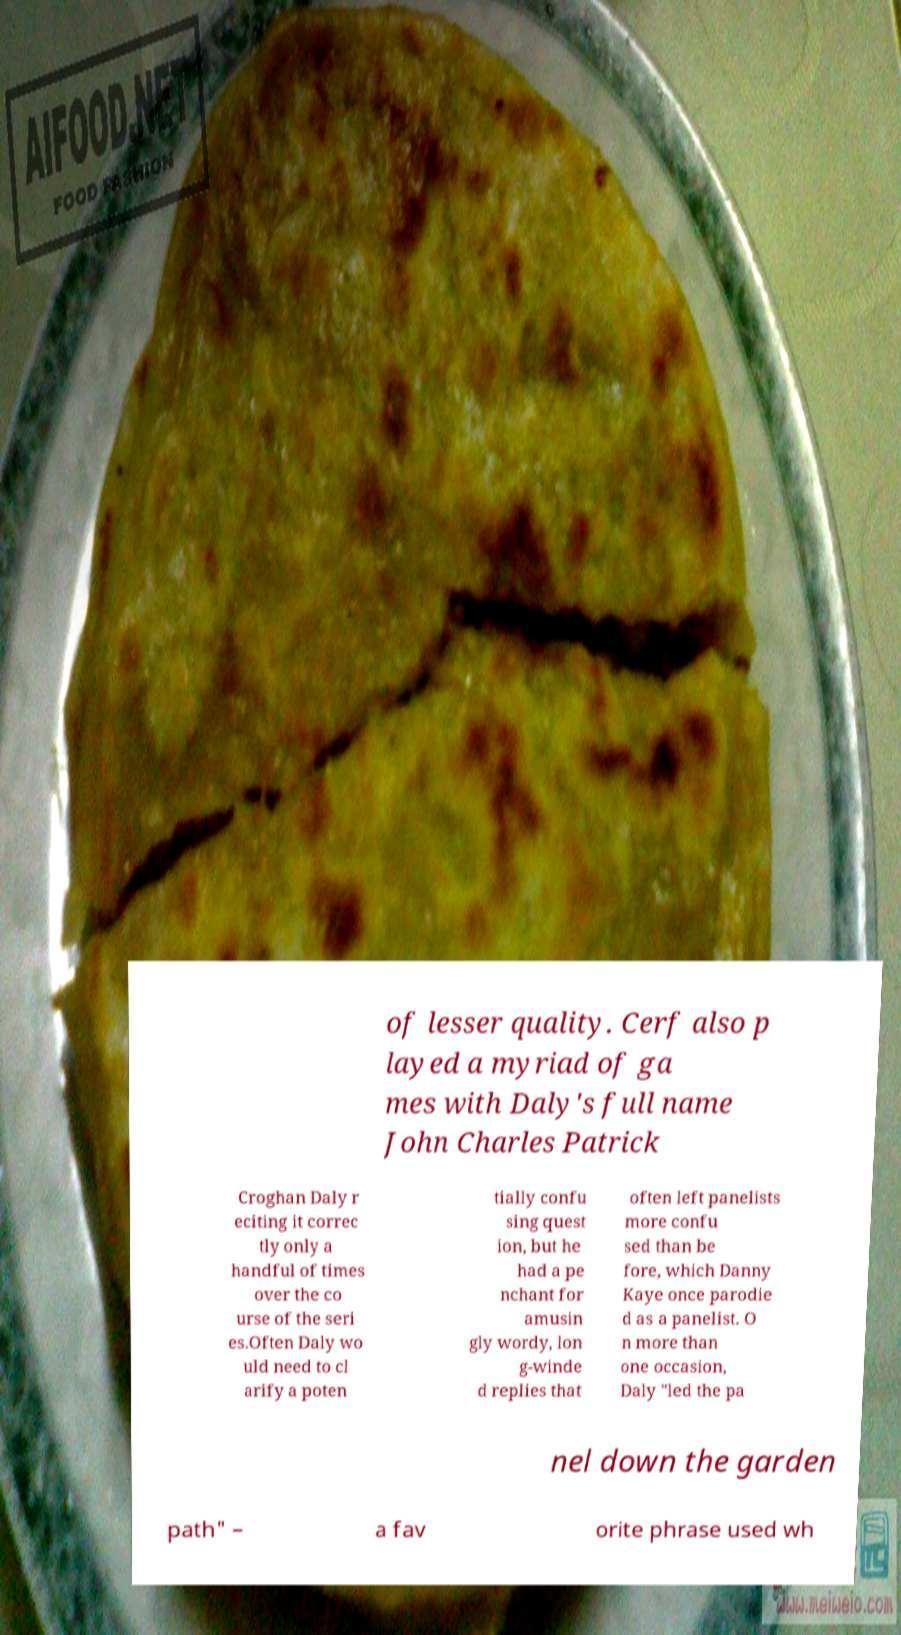Could you extract and type out the text from this image? of lesser quality. Cerf also p layed a myriad of ga mes with Daly's full name John Charles Patrick Croghan Daly r eciting it correc tly only a handful of times over the co urse of the seri es.Often Daly wo uld need to cl arify a poten tially confu sing quest ion, but he had a pe nchant for amusin gly wordy, lon g-winde d replies that often left panelists more confu sed than be fore, which Danny Kaye once parodie d as a panelist. O n more than one occasion, Daly "led the pa nel down the garden path" – a fav orite phrase used wh 